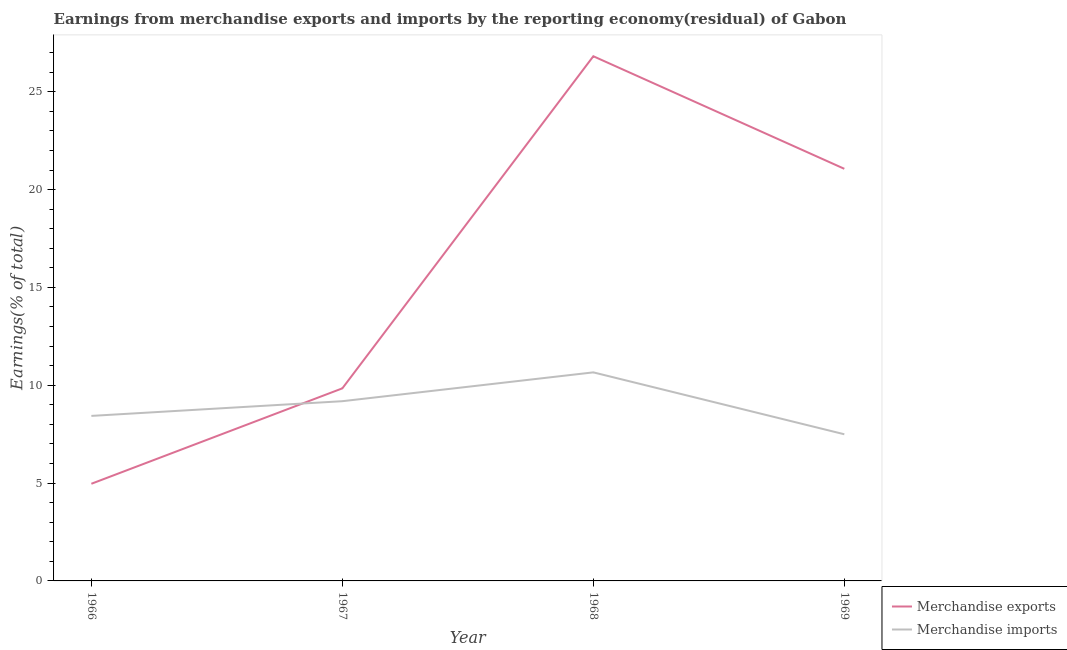How many different coloured lines are there?
Provide a short and direct response. 2. Does the line corresponding to earnings from merchandise imports intersect with the line corresponding to earnings from merchandise exports?
Offer a very short reply. Yes. Is the number of lines equal to the number of legend labels?
Your response must be concise. Yes. What is the earnings from merchandise exports in 1967?
Your answer should be very brief. 9.84. Across all years, what is the maximum earnings from merchandise imports?
Offer a very short reply. 10.66. Across all years, what is the minimum earnings from merchandise imports?
Keep it short and to the point. 7.49. In which year was the earnings from merchandise imports maximum?
Ensure brevity in your answer.  1968. In which year was the earnings from merchandise exports minimum?
Offer a terse response. 1966. What is the total earnings from merchandise imports in the graph?
Offer a very short reply. 35.77. What is the difference between the earnings from merchandise imports in 1967 and that in 1969?
Give a very brief answer. 1.69. What is the difference between the earnings from merchandise exports in 1969 and the earnings from merchandise imports in 1967?
Your response must be concise. 11.88. What is the average earnings from merchandise exports per year?
Offer a very short reply. 15.67. In the year 1967, what is the difference between the earnings from merchandise imports and earnings from merchandise exports?
Your response must be concise. -0.66. In how many years, is the earnings from merchandise imports greater than 14 %?
Your response must be concise. 0. What is the ratio of the earnings from merchandise imports in 1966 to that in 1969?
Make the answer very short. 1.13. Is the earnings from merchandise imports in 1968 less than that in 1969?
Your response must be concise. No. What is the difference between the highest and the second highest earnings from merchandise imports?
Your answer should be compact. 1.47. What is the difference between the highest and the lowest earnings from merchandise imports?
Keep it short and to the point. 3.16. Does the earnings from merchandise exports monotonically increase over the years?
Your answer should be very brief. No. How many lines are there?
Offer a terse response. 2. What is the difference between two consecutive major ticks on the Y-axis?
Keep it short and to the point. 5. Does the graph contain any zero values?
Keep it short and to the point. No. Does the graph contain grids?
Your answer should be very brief. No. Where does the legend appear in the graph?
Offer a terse response. Bottom right. What is the title of the graph?
Provide a succinct answer. Earnings from merchandise exports and imports by the reporting economy(residual) of Gabon. What is the label or title of the X-axis?
Ensure brevity in your answer.  Year. What is the label or title of the Y-axis?
Ensure brevity in your answer.  Earnings(% of total). What is the Earnings(% of total) of Merchandise exports in 1966?
Your answer should be very brief. 4.97. What is the Earnings(% of total) of Merchandise imports in 1966?
Offer a terse response. 8.43. What is the Earnings(% of total) in Merchandise exports in 1967?
Your answer should be compact. 9.84. What is the Earnings(% of total) in Merchandise imports in 1967?
Make the answer very short. 9.19. What is the Earnings(% of total) in Merchandise exports in 1968?
Ensure brevity in your answer.  26.81. What is the Earnings(% of total) of Merchandise imports in 1968?
Give a very brief answer. 10.66. What is the Earnings(% of total) in Merchandise exports in 1969?
Provide a short and direct response. 21.06. What is the Earnings(% of total) in Merchandise imports in 1969?
Your answer should be very brief. 7.49. Across all years, what is the maximum Earnings(% of total) of Merchandise exports?
Your response must be concise. 26.81. Across all years, what is the maximum Earnings(% of total) in Merchandise imports?
Make the answer very short. 10.66. Across all years, what is the minimum Earnings(% of total) in Merchandise exports?
Give a very brief answer. 4.97. Across all years, what is the minimum Earnings(% of total) of Merchandise imports?
Keep it short and to the point. 7.49. What is the total Earnings(% of total) of Merchandise exports in the graph?
Ensure brevity in your answer.  62.68. What is the total Earnings(% of total) of Merchandise imports in the graph?
Provide a short and direct response. 35.77. What is the difference between the Earnings(% of total) in Merchandise exports in 1966 and that in 1967?
Offer a very short reply. -4.88. What is the difference between the Earnings(% of total) of Merchandise imports in 1966 and that in 1967?
Your response must be concise. -0.75. What is the difference between the Earnings(% of total) of Merchandise exports in 1966 and that in 1968?
Offer a very short reply. -21.85. What is the difference between the Earnings(% of total) of Merchandise imports in 1966 and that in 1968?
Provide a succinct answer. -2.22. What is the difference between the Earnings(% of total) in Merchandise exports in 1966 and that in 1969?
Give a very brief answer. -16.1. What is the difference between the Earnings(% of total) in Merchandise imports in 1966 and that in 1969?
Give a very brief answer. 0.94. What is the difference between the Earnings(% of total) of Merchandise exports in 1967 and that in 1968?
Provide a succinct answer. -16.97. What is the difference between the Earnings(% of total) of Merchandise imports in 1967 and that in 1968?
Provide a short and direct response. -1.47. What is the difference between the Earnings(% of total) in Merchandise exports in 1967 and that in 1969?
Keep it short and to the point. -11.22. What is the difference between the Earnings(% of total) in Merchandise imports in 1967 and that in 1969?
Keep it short and to the point. 1.69. What is the difference between the Earnings(% of total) in Merchandise exports in 1968 and that in 1969?
Offer a very short reply. 5.75. What is the difference between the Earnings(% of total) in Merchandise imports in 1968 and that in 1969?
Ensure brevity in your answer.  3.16. What is the difference between the Earnings(% of total) in Merchandise exports in 1966 and the Earnings(% of total) in Merchandise imports in 1967?
Your response must be concise. -4.22. What is the difference between the Earnings(% of total) of Merchandise exports in 1966 and the Earnings(% of total) of Merchandise imports in 1968?
Keep it short and to the point. -5.69. What is the difference between the Earnings(% of total) in Merchandise exports in 1966 and the Earnings(% of total) in Merchandise imports in 1969?
Provide a short and direct response. -2.53. What is the difference between the Earnings(% of total) of Merchandise exports in 1967 and the Earnings(% of total) of Merchandise imports in 1968?
Ensure brevity in your answer.  -0.82. What is the difference between the Earnings(% of total) of Merchandise exports in 1967 and the Earnings(% of total) of Merchandise imports in 1969?
Make the answer very short. 2.35. What is the difference between the Earnings(% of total) of Merchandise exports in 1968 and the Earnings(% of total) of Merchandise imports in 1969?
Your answer should be very brief. 19.32. What is the average Earnings(% of total) of Merchandise exports per year?
Provide a succinct answer. 15.67. What is the average Earnings(% of total) in Merchandise imports per year?
Your response must be concise. 8.94. In the year 1966, what is the difference between the Earnings(% of total) in Merchandise exports and Earnings(% of total) in Merchandise imports?
Your answer should be very brief. -3.47. In the year 1967, what is the difference between the Earnings(% of total) of Merchandise exports and Earnings(% of total) of Merchandise imports?
Make the answer very short. 0.66. In the year 1968, what is the difference between the Earnings(% of total) in Merchandise exports and Earnings(% of total) in Merchandise imports?
Provide a short and direct response. 16.16. In the year 1969, what is the difference between the Earnings(% of total) of Merchandise exports and Earnings(% of total) of Merchandise imports?
Your answer should be very brief. 13.57. What is the ratio of the Earnings(% of total) in Merchandise exports in 1966 to that in 1967?
Your answer should be very brief. 0.5. What is the ratio of the Earnings(% of total) in Merchandise imports in 1966 to that in 1967?
Your answer should be very brief. 0.92. What is the ratio of the Earnings(% of total) of Merchandise exports in 1966 to that in 1968?
Offer a terse response. 0.19. What is the ratio of the Earnings(% of total) of Merchandise imports in 1966 to that in 1968?
Ensure brevity in your answer.  0.79. What is the ratio of the Earnings(% of total) of Merchandise exports in 1966 to that in 1969?
Ensure brevity in your answer.  0.24. What is the ratio of the Earnings(% of total) of Merchandise imports in 1966 to that in 1969?
Your answer should be compact. 1.13. What is the ratio of the Earnings(% of total) in Merchandise exports in 1967 to that in 1968?
Keep it short and to the point. 0.37. What is the ratio of the Earnings(% of total) of Merchandise imports in 1967 to that in 1968?
Keep it short and to the point. 0.86. What is the ratio of the Earnings(% of total) in Merchandise exports in 1967 to that in 1969?
Ensure brevity in your answer.  0.47. What is the ratio of the Earnings(% of total) of Merchandise imports in 1967 to that in 1969?
Provide a succinct answer. 1.23. What is the ratio of the Earnings(% of total) in Merchandise exports in 1968 to that in 1969?
Keep it short and to the point. 1.27. What is the ratio of the Earnings(% of total) of Merchandise imports in 1968 to that in 1969?
Your answer should be compact. 1.42. What is the difference between the highest and the second highest Earnings(% of total) in Merchandise exports?
Keep it short and to the point. 5.75. What is the difference between the highest and the second highest Earnings(% of total) of Merchandise imports?
Give a very brief answer. 1.47. What is the difference between the highest and the lowest Earnings(% of total) in Merchandise exports?
Ensure brevity in your answer.  21.85. What is the difference between the highest and the lowest Earnings(% of total) of Merchandise imports?
Your response must be concise. 3.16. 